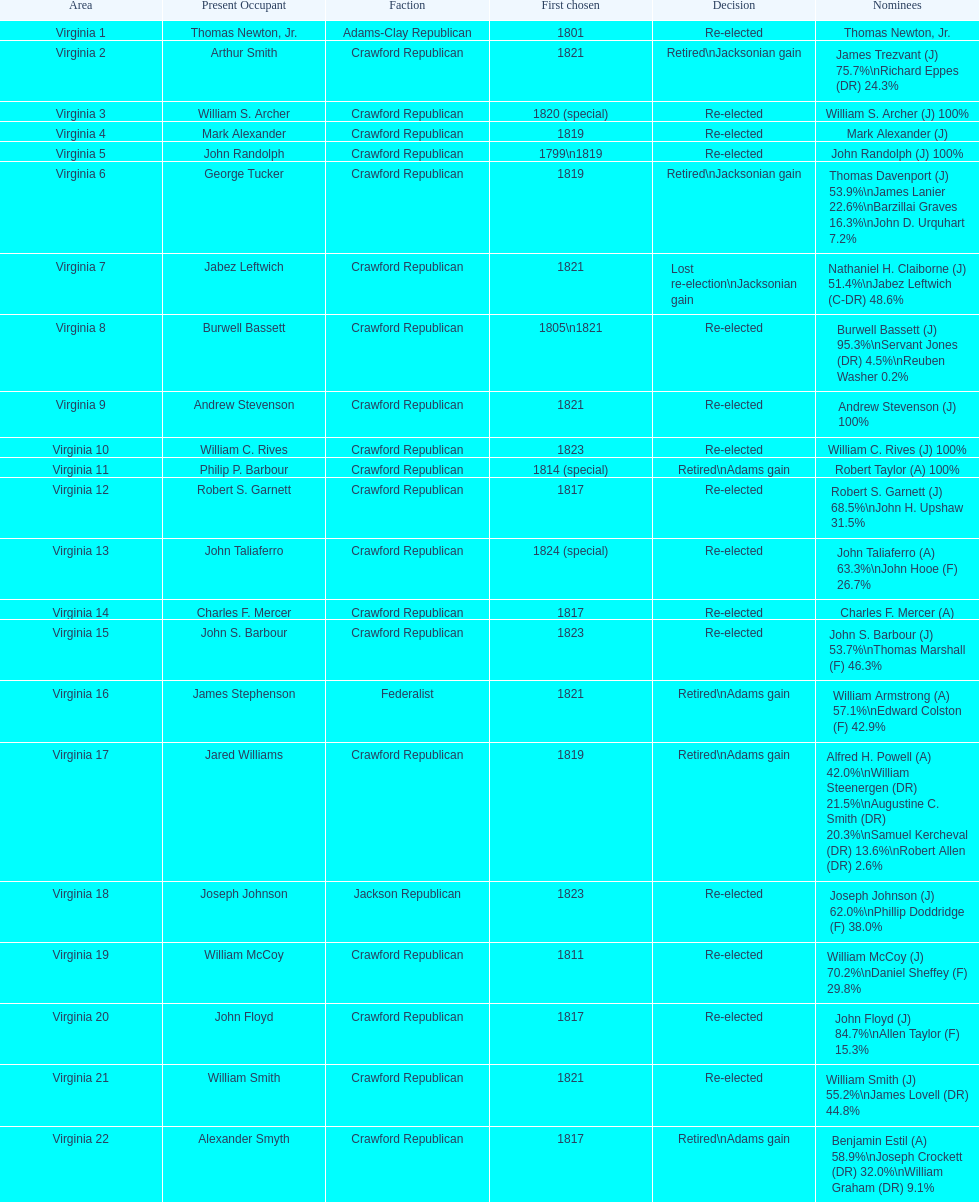Who was the next incumbent after john randolph? George Tucker. 